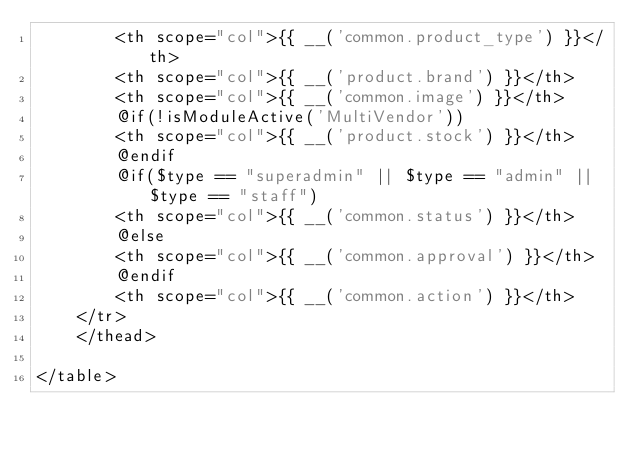<code> <loc_0><loc_0><loc_500><loc_500><_PHP_>        <th scope="col">{{ __('common.product_type') }}</th>
        <th scope="col">{{ __('product.brand') }}</th>
        <th scope="col">{{ __('common.image') }}</th>
        @if(!isModuleActive('MultiVendor'))
        <th scope="col">{{ __('product.stock') }}</th>
        @endif
        @if($type == "superadmin" || $type == "admin" || $type == "staff")
        <th scope="col">{{ __('common.status') }}</th>
        @else
        <th scope="col">{{ __('common.approval') }}</th>
        @endif
        <th scope="col">{{ __('common.action') }}</th>
    </tr>
    </thead>
    
</table>
</code> 